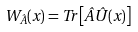Convert formula to latex. <formula><loc_0><loc_0><loc_500><loc_500>W _ { \hat { A } } ( { x } ) = T r \left [ \hat { A } \hat { U } ( { x } ) \right ]</formula> 